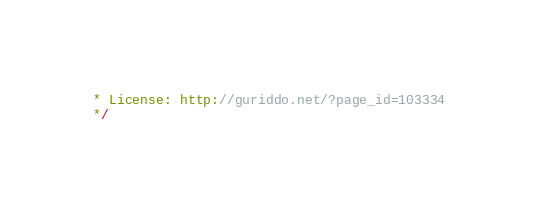<code> <loc_0><loc_0><loc_500><loc_500><_JavaScript_>* License: http://guriddo.net/?page_id=103334
*/</code> 